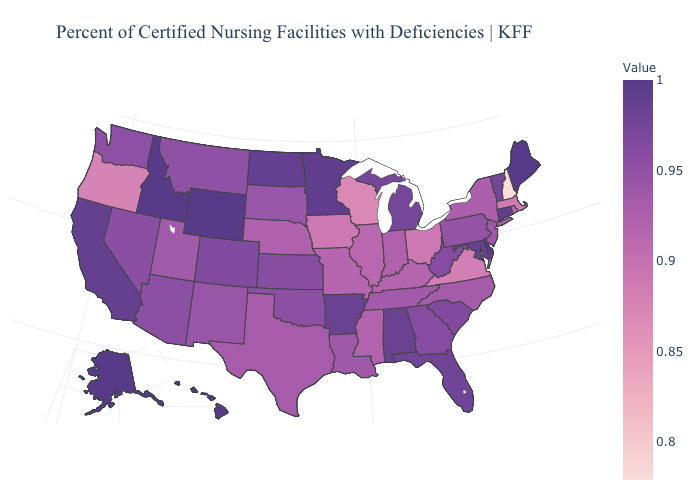Which states have the highest value in the USA?
Be succinct. Alaska, Delaware, Hawaii, Idaho, Maine, Wyoming. Does Ohio have the highest value in the USA?
Concise answer only. No. Among the states that border New Jersey , does Pennsylvania have the highest value?
Concise answer only. No. Among the states that border Kansas , does Oklahoma have the lowest value?
Give a very brief answer. No. Does Arkansas have the highest value in the USA?
Keep it brief. No. Does Connecticut have the lowest value in the USA?
Keep it brief. No. 